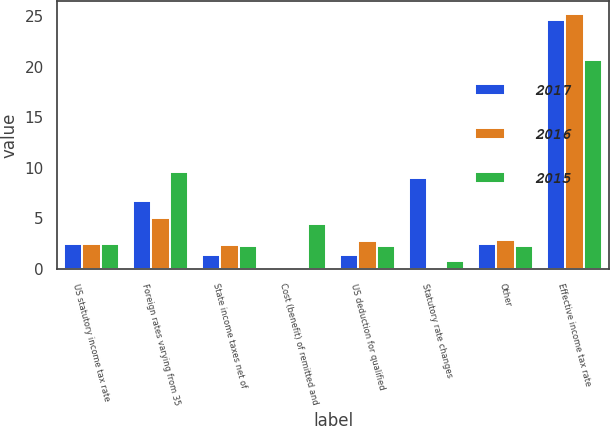Convert chart to OTSL. <chart><loc_0><loc_0><loc_500><loc_500><stacked_bar_chart><ecel><fcel>US statutory income tax rate<fcel>Foreign rates varying from 35<fcel>State income taxes net of<fcel>Cost (benefit) of remitted and<fcel>US deduction for qualified<fcel>Statutory rate changes<fcel>Other<fcel>Effective income tax rate<nl><fcel>2017<fcel>2.5<fcel>6.7<fcel>1.4<fcel>0.1<fcel>1.4<fcel>9<fcel>2.5<fcel>24.6<nl><fcel>2016<fcel>2.5<fcel>5<fcel>2.4<fcel>0.1<fcel>2.8<fcel>0.1<fcel>2.9<fcel>25.2<nl><fcel>2015<fcel>2.5<fcel>9.6<fcel>2.3<fcel>4.4<fcel>2.3<fcel>0.8<fcel>2.3<fcel>20.6<nl></chart> 